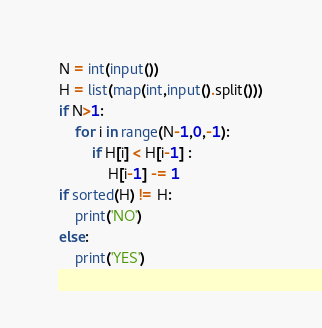Convert code to text. <code><loc_0><loc_0><loc_500><loc_500><_Python_>N = int(input())
H = list(map(int,input().split()))
if N>1:
    for i in range(N-1,0,-1):
        if H[i] < H[i-1] :
            H[i-1] -= 1
if sorted(H) != H:
    print('NO')
else:
    print('YES')</code> 